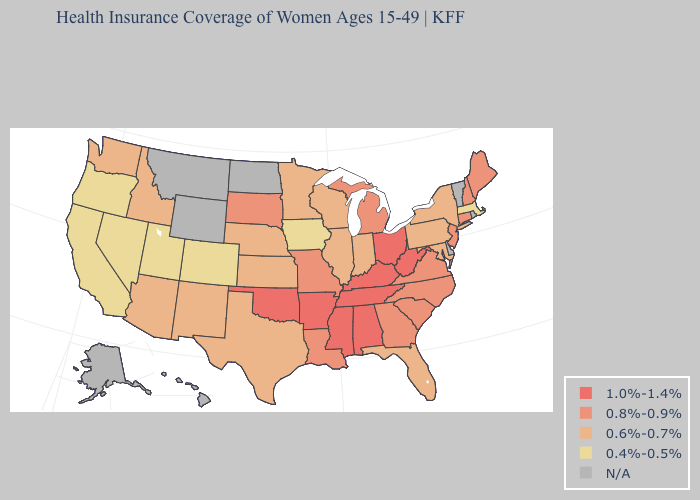Does Oregon have the highest value in the West?
Be succinct. No. Is the legend a continuous bar?
Short answer required. No. What is the lowest value in states that border South Dakota?
Quick response, please. 0.4%-0.5%. Is the legend a continuous bar?
Keep it brief. No. Name the states that have a value in the range N/A?
Answer briefly. Alaska, Delaware, Hawaii, Montana, North Dakota, Rhode Island, Vermont, Wyoming. Name the states that have a value in the range 0.6%-0.7%?
Answer briefly. Arizona, Florida, Idaho, Illinois, Indiana, Kansas, Maryland, Minnesota, Nebraska, New Mexico, New York, Pennsylvania, Texas, Washington, Wisconsin. What is the value of North Dakota?
Be succinct. N/A. What is the value of New Jersey?
Write a very short answer. 0.8%-0.9%. What is the value of Massachusetts?
Be succinct. 0.4%-0.5%. Which states hav the highest value in the MidWest?
Answer briefly. Ohio. What is the highest value in the USA?
Give a very brief answer. 1.0%-1.4%. Which states hav the highest value in the MidWest?
Write a very short answer. Ohio. What is the lowest value in states that border North Carolina?
Give a very brief answer. 0.8%-0.9%. What is the lowest value in the Northeast?
Give a very brief answer. 0.4%-0.5%. 